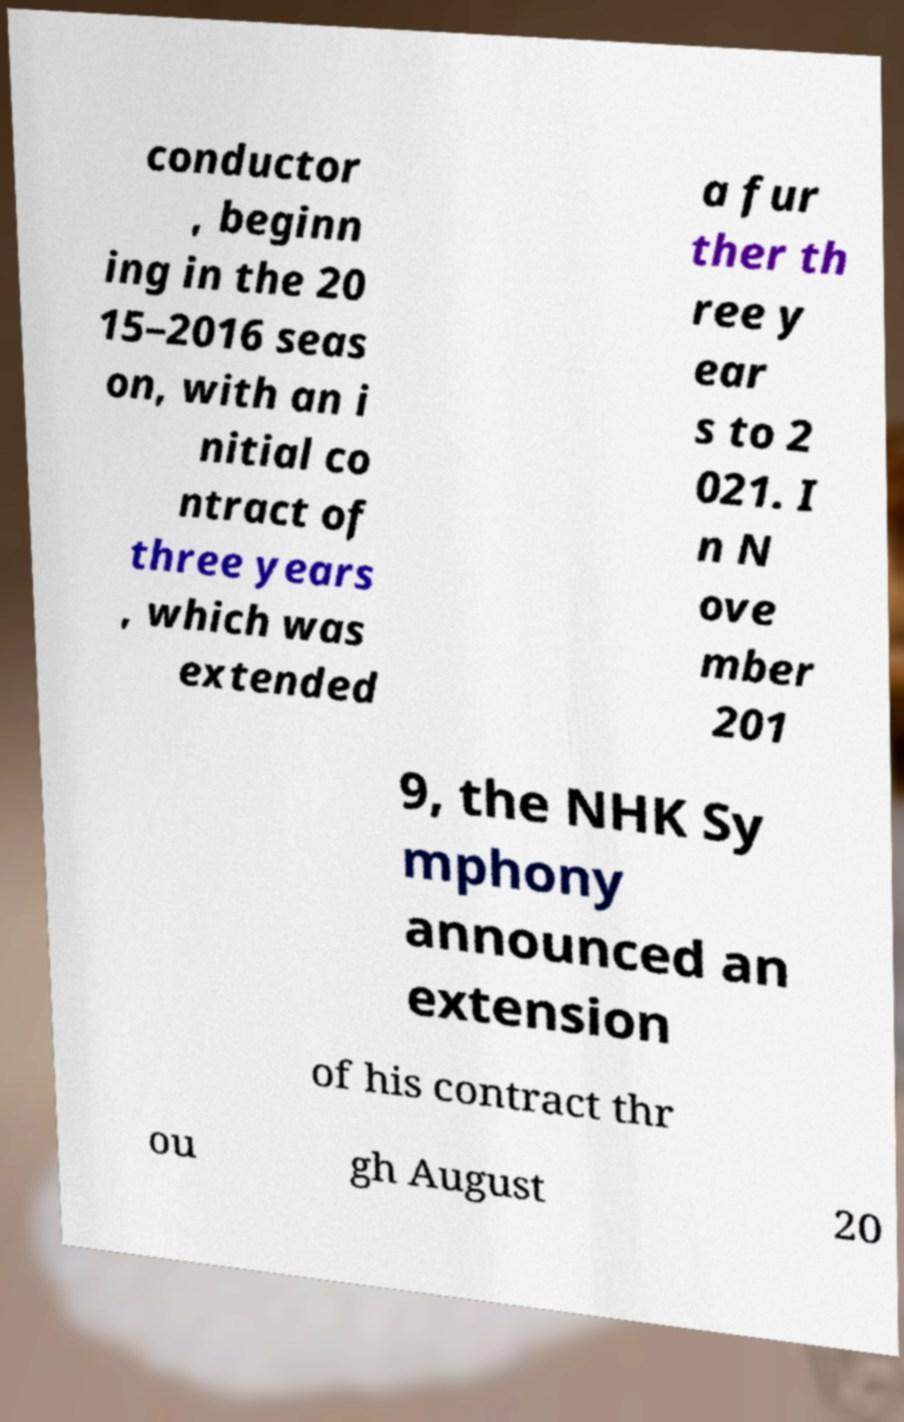What messages or text are displayed in this image? I need them in a readable, typed format. conductor , beginn ing in the 20 15–2016 seas on, with an i nitial co ntract of three years , which was extended a fur ther th ree y ear s to 2 021. I n N ove mber 201 9, the NHK Sy mphony announced an extension of his contract thr ou gh August 20 